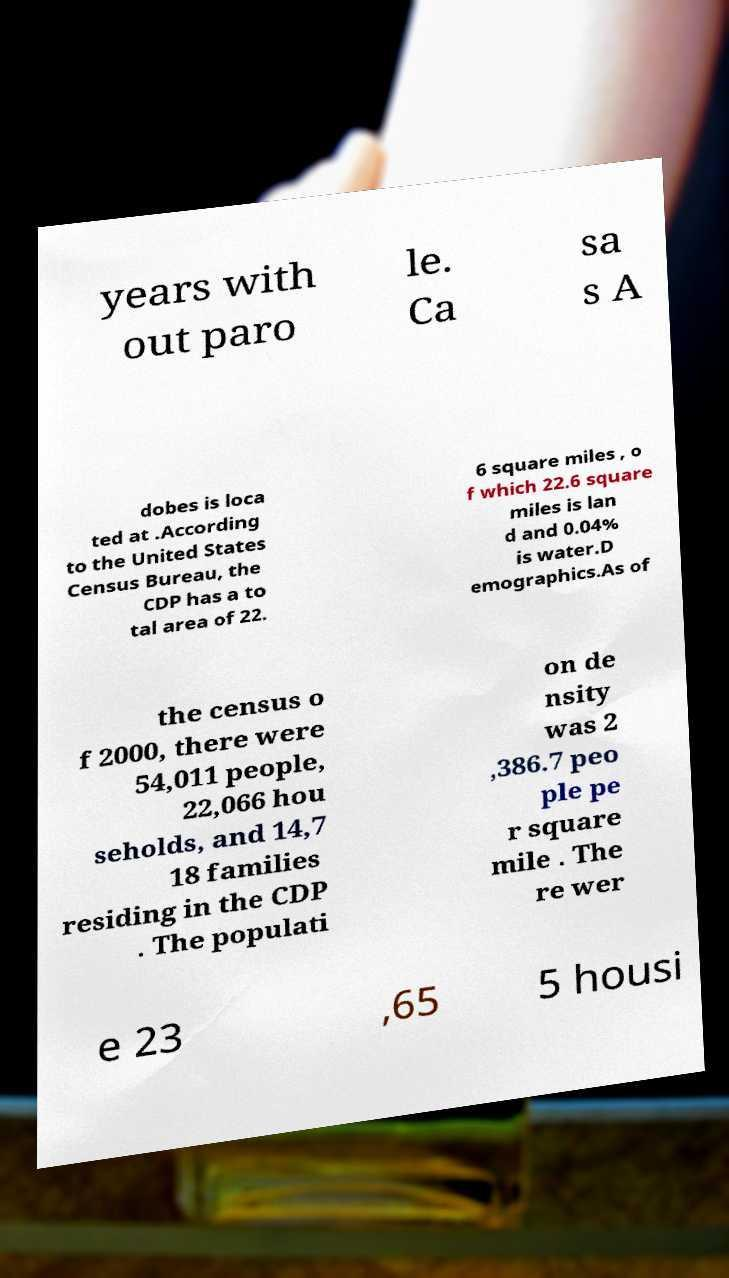Could you extract and type out the text from this image? years with out paro le. Ca sa s A dobes is loca ted at .According to the United States Census Bureau, the CDP has a to tal area of 22. 6 square miles , o f which 22.6 square miles is lan d and 0.04% is water.D emographics.As of the census o f 2000, there were 54,011 people, 22,066 hou seholds, and 14,7 18 families residing in the CDP . The populati on de nsity was 2 ,386.7 peo ple pe r square mile . The re wer e 23 ,65 5 housi 